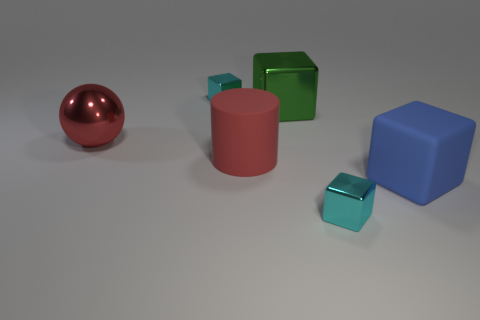Subtract all big green metallic blocks. How many blocks are left? 3 Subtract all cyan spheres. How many cyan blocks are left? 2 Subtract 1 cubes. How many cubes are left? 3 Subtract all green cubes. How many cubes are left? 3 Add 2 red matte objects. How many objects exist? 8 Subtract 0 gray cubes. How many objects are left? 6 Subtract all balls. How many objects are left? 5 Subtract all purple cubes. Subtract all gray cylinders. How many cubes are left? 4 Subtract all red things. Subtract all metal things. How many objects are left? 0 Add 4 small cubes. How many small cubes are left? 6 